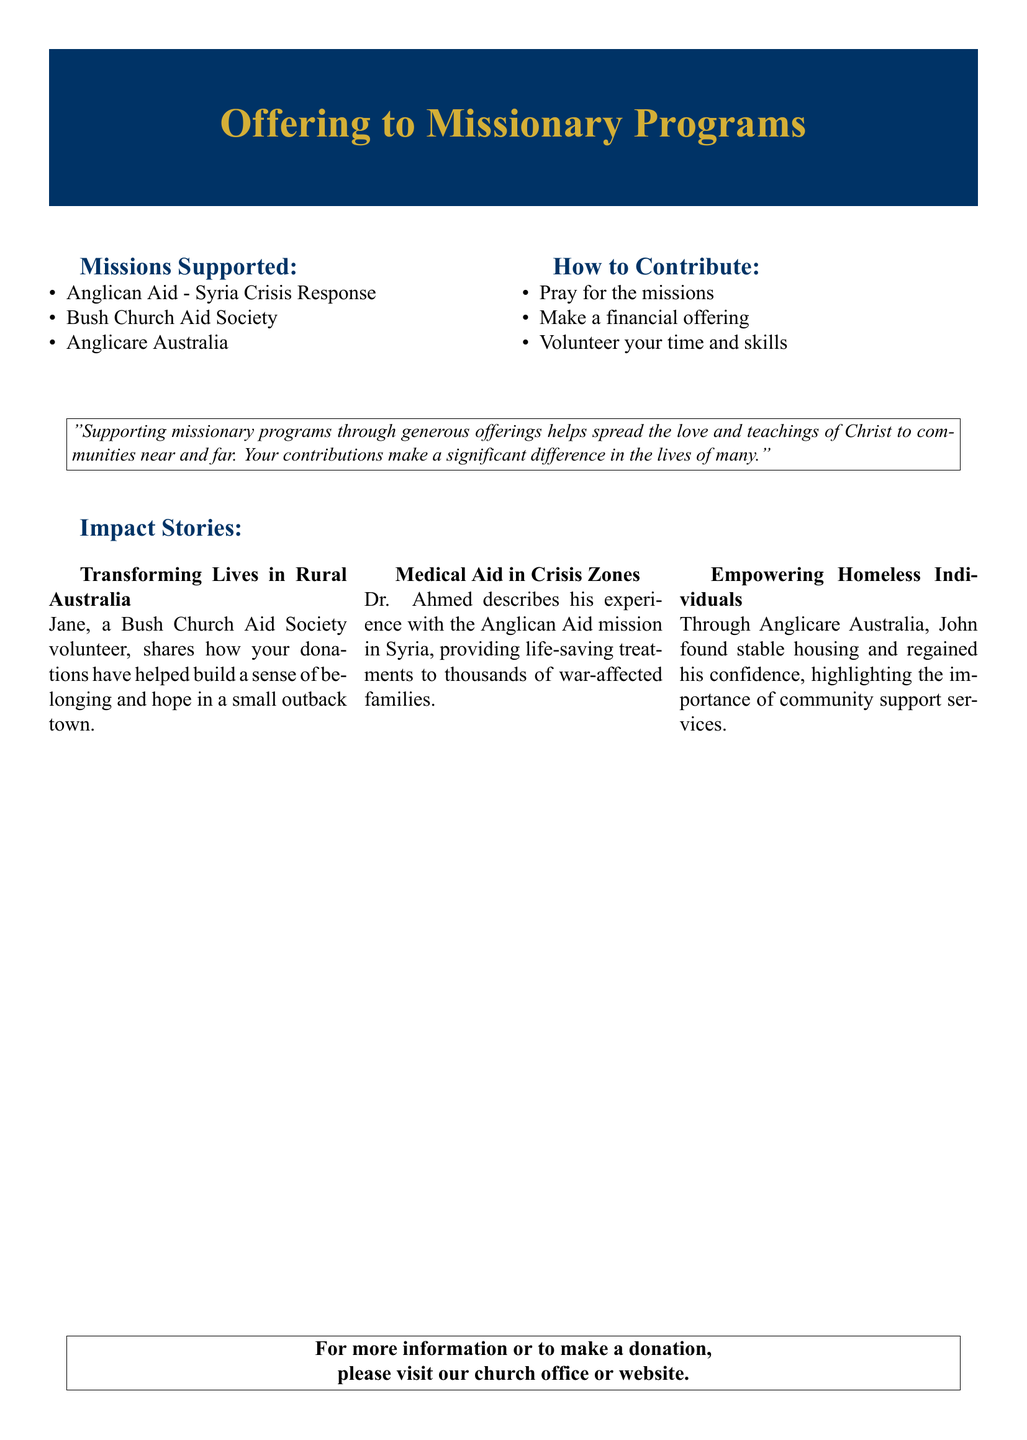What are the missions supported? The missions supported are listed in the document, including Anglican Aid, Bush Church Aid Society, and Anglicare Australia.
Answer: Anglican Aid, Bush Church Aid Society, Anglicare Australia How can you contribute? The document outlines the ways to contribute, including praying, making a financial offering, and volunteering time and skills.
Answer: Pray, make a financial offering, volunteer Who shared the impact story about rural Australia? The impact story in rural Australia was shared by Jane, a volunteer for the Bush Church Aid Society.
Answer: Jane What is the focus of Dr. Ahmed's mission? Dr. Ahmed's mission focuses on providing medical aid in crisis zones, particularly in Syria.
Answer: Medical aid in crisis zones What has Anglicare Australia helped John to regain? John highlights that Anglicare Australia helped him regain his confidence after finding stable housing.
Answer: Confidence What does the quote in the document emphasize? The quote emphasizes the significant difference that generous offerings make in spreading the love and teachings of Christ.
Answer: Generous offerings' difference What is the document type? The type of document presented is a Gift voucher related to missionary programs.
Answer: Gift voucher How many impact stories are presented? The document presents a total of three impact stories from different missions.
Answer: Three 